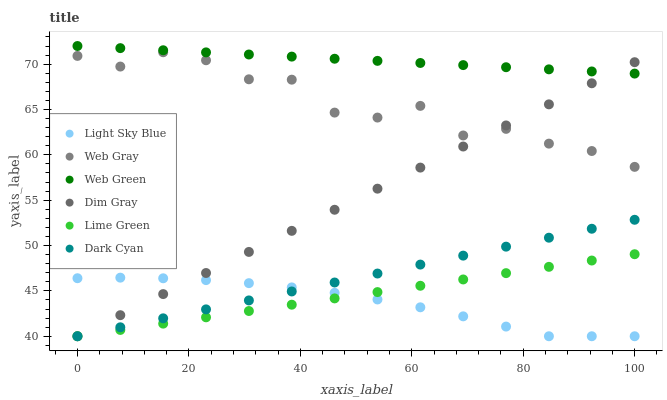Does Light Sky Blue have the minimum area under the curve?
Answer yes or no. Yes. Does Web Green have the maximum area under the curve?
Answer yes or no. Yes. Does Web Green have the minimum area under the curve?
Answer yes or no. No. Does Light Sky Blue have the maximum area under the curve?
Answer yes or no. No. Is Lime Green the smoothest?
Answer yes or no. Yes. Is Web Gray the roughest?
Answer yes or no. Yes. Is Web Green the smoothest?
Answer yes or no. No. Is Web Green the roughest?
Answer yes or no. No. Does Dim Gray have the lowest value?
Answer yes or no. Yes. Does Web Green have the lowest value?
Answer yes or no. No. Does Web Green have the highest value?
Answer yes or no. Yes. Does Light Sky Blue have the highest value?
Answer yes or no. No. Is Dark Cyan less than Web Gray?
Answer yes or no. Yes. Is Web Green greater than Light Sky Blue?
Answer yes or no. Yes. Does Lime Green intersect Dark Cyan?
Answer yes or no. Yes. Is Lime Green less than Dark Cyan?
Answer yes or no. No. Is Lime Green greater than Dark Cyan?
Answer yes or no. No. Does Dark Cyan intersect Web Gray?
Answer yes or no. No. 